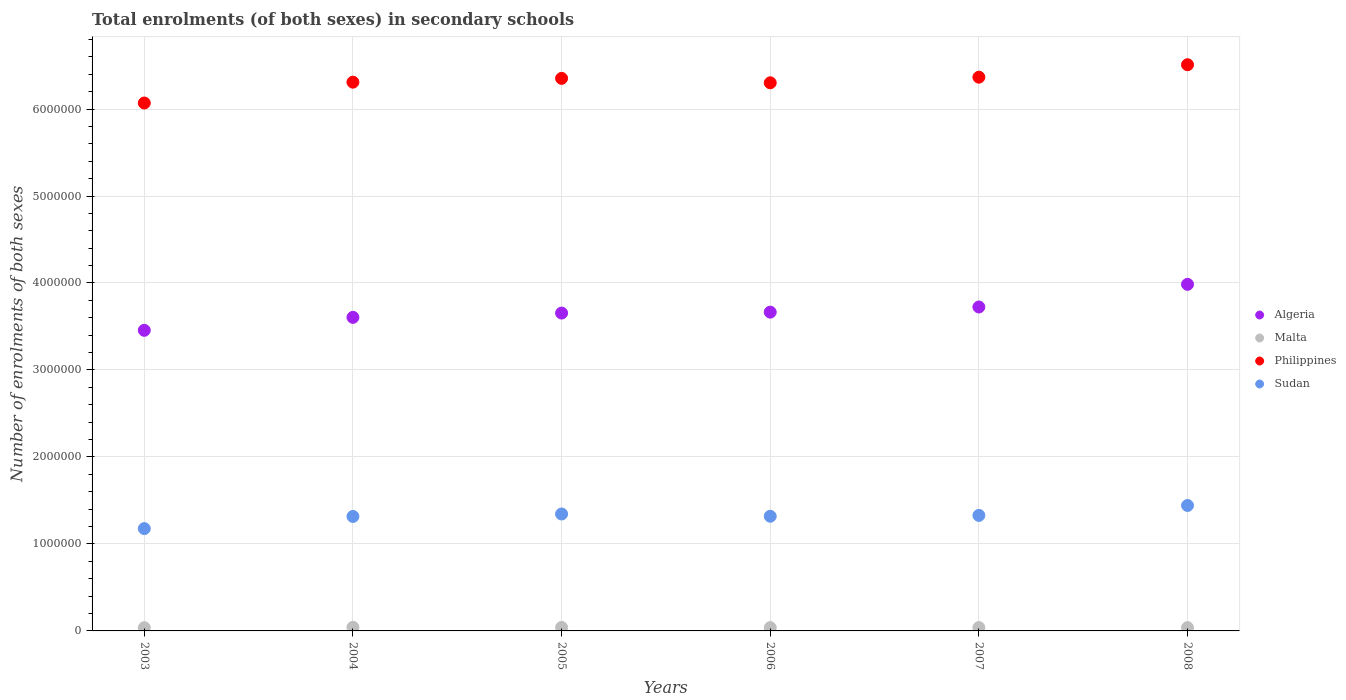What is the number of enrolments in secondary schools in Sudan in 2004?
Keep it short and to the point. 1.32e+06. Across all years, what is the maximum number of enrolments in secondary schools in Sudan?
Make the answer very short. 1.44e+06. Across all years, what is the minimum number of enrolments in secondary schools in Sudan?
Your response must be concise. 1.18e+06. In which year was the number of enrolments in secondary schools in Philippines maximum?
Offer a very short reply. 2008. In which year was the number of enrolments in secondary schools in Philippines minimum?
Keep it short and to the point. 2003. What is the total number of enrolments in secondary schools in Sudan in the graph?
Offer a very short reply. 7.92e+06. What is the difference between the number of enrolments in secondary schools in Philippines in 2007 and that in 2008?
Offer a terse response. -1.43e+05. What is the difference between the number of enrolments in secondary schools in Algeria in 2003 and the number of enrolments in secondary schools in Malta in 2008?
Keep it short and to the point. 3.42e+06. What is the average number of enrolments in secondary schools in Philippines per year?
Provide a short and direct response. 6.32e+06. In the year 2005, what is the difference between the number of enrolments in secondary schools in Sudan and number of enrolments in secondary schools in Philippines?
Make the answer very short. -5.01e+06. In how many years, is the number of enrolments in secondary schools in Algeria greater than 6600000?
Offer a terse response. 0. What is the ratio of the number of enrolments in secondary schools in Malta in 2004 to that in 2007?
Make the answer very short. 1.07. What is the difference between the highest and the second highest number of enrolments in secondary schools in Philippines?
Your answer should be compact. 1.43e+05. What is the difference between the highest and the lowest number of enrolments in secondary schools in Malta?
Provide a short and direct response. 4375. In how many years, is the number of enrolments in secondary schools in Philippines greater than the average number of enrolments in secondary schools in Philippines taken over all years?
Ensure brevity in your answer.  3. Is it the case that in every year, the sum of the number of enrolments in secondary schools in Sudan and number of enrolments in secondary schools in Malta  is greater than the number of enrolments in secondary schools in Algeria?
Your answer should be compact. No. Does the number of enrolments in secondary schools in Philippines monotonically increase over the years?
Your answer should be compact. No. Is the number of enrolments in secondary schools in Philippines strictly less than the number of enrolments in secondary schools in Malta over the years?
Your answer should be very brief. No. How many years are there in the graph?
Ensure brevity in your answer.  6. What is the difference between two consecutive major ticks on the Y-axis?
Provide a succinct answer. 1.00e+06. Does the graph contain grids?
Provide a short and direct response. Yes. What is the title of the graph?
Make the answer very short. Total enrolments (of both sexes) in secondary schools. What is the label or title of the X-axis?
Offer a terse response. Years. What is the label or title of the Y-axis?
Your response must be concise. Number of enrolments of both sexes. What is the Number of enrolments of both sexes in Algeria in 2003?
Make the answer very short. 3.46e+06. What is the Number of enrolments of both sexes in Malta in 2003?
Ensure brevity in your answer.  3.70e+04. What is the Number of enrolments of both sexes in Philippines in 2003?
Your answer should be very brief. 6.07e+06. What is the Number of enrolments of both sexes in Sudan in 2003?
Make the answer very short. 1.18e+06. What is the Number of enrolments of both sexes in Algeria in 2004?
Make the answer very short. 3.60e+06. What is the Number of enrolments of both sexes of Malta in 2004?
Your response must be concise. 4.14e+04. What is the Number of enrolments of both sexes in Philippines in 2004?
Make the answer very short. 6.31e+06. What is the Number of enrolments of both sexes of Sudan in 2004?
Ensure brevity in your answer.  1.32e+06. What is the Number of enrolments of both sexes of Algeria in 2005?
Your answer should be compact. 3.65e+06. What is the Number of enrolments of both sexes in Malta in 2005?
Your answer should be compact. 4.01e+04. What is the Number of enrolments of both sexes of Philippines in 2005?
Your answer should be compact. 6.35e+06. What is the Number of enrolments of both sexes of Sudan in 2005?
Offer a terse response. 1.34e+06. What is the Number of enrolments of both sexes in Algeria in 2006?
Your response must be concise. 3.66e+06. What is the Number of enrolments of both sexes of Malta in 2006?
Provide a succinct answer. 3.83e+04. What is the Number of enrolments of both sexes of Philippines in 2006?
Your answer should be very brief. 6.30e+06. What is the Number of enrolments of both sexes in Sudan in 2006?
Offer a very short reply. 1.32e+06. What is the Number of enrolments of both sexes in Algeria in 2007?
Provide a short and direct response. 3.72e+06. What is the Number of enrolments of both sexes of Malta in 2007?
Offer a very short reply. 3.85e+04. What is the Number of enrolments of both sexes in Philippines in 2007?
Your answer should be very brief. 6.37e+06. What is the Number of enrolments of both sexes of Sudan in 2007?
Your answer should be very brief. 1.33e+06. What is the Number of enrolments of both sexes in Algeria in 2008?
Make the answer very short. 3.98e+06. What is the Number of enrolments of both sexes of Malta in 2008?
Make the answer very short. 3.78e+04. What is the Number of enrolments of both sexes in Philippines in 2008?
Provide a succinct answer. 6.51e+06. What is the Number of enrolments of both sexes of Sudan in 2008?
Provide a short and direct response. 1.44e+06. Across all years, what is the maximum Number of enrolments of both sexes in Algeria?
Keep it short and to the point. 3.98e+06. Across all years, what is the maximum Number of enrolments of both sexes of Malta?
Offer a very short reply. 4.14e+04. Across all years, what is the maximum Number of enrolments of both sexes in Philippines?
Offer a terse response. 6.51e+06. Across all years, what is the maximum Number of enrolments of both sexes of Sudan?
Keep it short and to the point. 1.44e+06. Across all years, what is the minimum Number of enrolments of both sexes of Algeria?
Provide a short and direct response. 3.46e+06. Across all years, what is the minimum Number of enrolments of both sexes of Malta?
Your answer should be very brief. 3.70e+04. Across all years, what is the minimum Number of enrolments of both sexes in Philippines?
Your response must be concise. 6.07e+06. Across all years, what is the minimum Number of enrolments of both sexes in Sudan?
Your response must be concise. 1.18e+06. What is the total Number of enrolments of both sexes of Algeria in the graph?
Provide a short and direct response. 2.21e+07. What is the total Number of enrolments of both sexes of Malta in the graph?
Ensure brevity in your answer.  2.33e+05. What is the total Number of enrolments of both sexes in Philippines in the graph?
Ensure brevity in your answer.  3.79e+07. What is the total Number of enrolments of both sexes of Sudan in the graph?
Your answer should be very brief. 7.92e+06. What is the difference between the Number of enrolments of both sexes of Algeria in 2003 and that in 2004?
Ensure brevity in your answer.  -1.49e+05. What is the difference between the Number of enrolments of both sexes of Malta in 2003 and that in 2004?
Offer a terse response. -4375. What is the difference between the Number of enrolments of both sexes in Philippines in 2003 and that in 2004?
Your response must be concise. -2.40e+05. What is the difference between the Number of enrolments of both sexes in Sudan in 2003 and that in 2004?
Your answer should be very brief. -1.40e+05. What is the difference between the Number of enrolments of both sexes of Algeria in 2003 and that in 2005?
Offer a terse response. -1.98e+05. What is the difference between the Number of enrolments of both sexes in Malta in 2003 and that in 2005?
Your answer should be compact. -3151. What is the difference between the Number of enrolments of both sexes of Philippines in 2003 and that in 2005?
Offer a terse response. -2.83e+05. What is the difference between the Number of enrolments of both sexes of Sudan in 2003 and that in 2005?
Your answer should be compact. -1.68e+05. What is the difference between the Number of enrolments of both sexes of Algeria in 2003 and that in 2006?
Offer a terse response. -2.09e+05. What is the difference between the Number of enrolments of both sexes of Malta in 2003 and that in 2006?
Provide a succinct answer. -1357. What is the difference between the Number of enrolments of both sexes in Philippines in 2003 and that in 2006?
Make the answer very short. -2.33e+05. What is the difference between the Number of enrolments of both sexes of Sudan in 2003 and that in 2006?
Your response must be concise. -1.42e+05. What is the difference between the Number of enrolments of both sexes in Algeria in 2003 and that in 2007?
Offer a terse response. -2.68e+05. What is the difference between the Number of enrolments of both sexes of Malta in 2003 and that in 2007?
Keep it short and to the point. -1521. What is the difference between the Number of enrolments of both sexes of Philippines in 2003 and that in 2007?
Offer a terse response. -2.97e+05. What is the difference between the Number of enrolments of both sexes in Sudan in 2003 and that in 2007?
Offer a terse response. -1.52e+05. What is the difference between the Number of enrolments of both sexes of Algeria in 2003 and that in 2008?
Ensure brevity in your answer.  -5.29e+05. What is the difference between the Number of enrolments of both sexes of Malta in 2003 and that in 2008?
Your answer should be compact. -796. What is the difference between the Number of enrolments of both sexes in Philippines in 2003 and that in 2008?
Offer a terse response. -4.40e+05. What is the difference between the Number of enrolments of both sexes in Sudan in 2003 and that in 2008?
Your answer should be compact. -2.66e+05. What is the difference between the Number of enrolments of both sexes of Algeria in 2004 and that in 2005?
Your answer should be very brief. -4.94e+04. What is the difference between the Number of enrolments of both sexes in Malta in 2004 and that in 2005?
Offer a terse response. 1224. What is the difference between the Number of enrolments of both sexes of Philippines in 2004 and that in 2005?
Provide a succinct answer. -4.37e+04. What is the difference between the Number of enrolments of both sexes of Sudan in 2004 and that in 2005?
Provide a succinct answer. -2.83e+04. What is the difference between the Number of enrolments of both sexes of Algeria in 2004 and that in 2006?
Give a very brief answer. -6.01e+04. What is the difference between the Number of enrolments of both sexes in Malta in 2004 and that in 2006?
Provide a succinct answer. 3018. What is the difference between the Number of enrolments of both sexes of Philippines in 2004 and that in 2006?
Ensure brevity in your answer.  7210. What is the difference between the Number of enrolments of both sexes of Sudan in 2004 and that in 2006?
Your answer should be very brief. -2099. What is the difference between the Number of enrolments of both sexes of Algeria in 2004 and that in 2007?
Offer a very short reply. -1.19e+05. What is the difference between the Number of enrolments of both sexes of Malta in 2004 and that in 2007?
Provide a succinct answer. 2854. What is the difference between the Number of enrolments of both sexes of Philippines in 2004 and that in 2007?
Keep it short and to the point. -5.72e+04. What is the difference between the Number of enrolments of both sexes in Sudan in 2004 and that in 2007?
Provide a succinct answer. -1.19e+04. What is the difference between the Number of enrolments of both sexes of Algeria in 2004 and that in 2008?
Keep it short and to the point. -3.80e+05. What is the difference between the Number of enrolments of both sexes of Malta in 2004 and that in 2008?
Provide a short and direct response. 3579. What is the difference between the Number of enrolments of both sexes of Philippines in 2004 and that in 2008?
Offer a very short reply. -2.00e+05. What is the difference between the Number of enrolments of both sexes in Sudan in 2004 and that in 2008?
Provide a succinct answer. -1.26e+05. What is the difference between the Number of enrolments of both sexes in Algeria in 2005 and that in 2006?
Keep it short and to the point. -1.06e+04. What is the difference between the Number of enrolments of both sexes of Malta in 2005 and that in 2006?
Give a very brief answer. 1794. What is the difference between the Number of enrolments of both sexes in Philippines in 2005 and that in 2006?
Provide a succinct answer. 5.09e+04. What is the difference between the Number of enrolments of both sexes in Sudan in 2005 and that in 2006?
Your response must be concise. 2.62e+04. What is the difference between the Number of enrolments of both sexes of Algeria in 2005 and that in 2007?
Make the answer very short. -6.99e+04. What is the difference between the Number of enrolments of both sexes in Malta in 2005 and that in 2007?
Your answer should be compact. 1630. What is the difference between the Number of enrolments of both sexes of Philippines in 2005 and that in 2007?
Your response must be concise. -1.35e+04. What is the difference between the Number of enrolments of both sexes of Sudan in 2005 and that in 2007?
Your answer should be compact. 1.64e+04. What is the difference between the Number of enrolments of both sexes in Algeria in 2005 and that in 2008?
Offer a very short reply. -3.30e+05. What is the difference between the Number of enrolments of both sexes of Malta in 2005 and that in 2008?
Ensure brevity in your answer.  2355. What is the difference between the Number of enrolments of both sexes of Philippines in 2005 and that in 2008?
Make the answer very short. -1.57e+05. What is the difference between the Number of enrolments of both sexes in Sudan in 2005 and that in 2008?
Your answer should be very brief. -9.78e+04. What is the difference between the Number of enrolments of both sexes of Algeria in 2006 and that in 2007?
Keep it short and to the point. -5.92e+04. What is the difference between the Number of enrolments of both sexes of Malta in 2006 and that in 2007?
Your answer should be very brief. -164. What is the difference between the Number of enrolments of both sexes in Philippines in 2006 and that in 2007?
Provide a short and direct response. -6.44e+04. What is the difference between the Number of enrolments of both sexes in Sudan in 2006 and that in 2007?
Your answer should be very brief. -9811. What is the difference between the Number of enrolments of both sexes in Algeria in 2006 and that in 2008?
Your answer should be compact. -3.20e+05. What is the difference between the Number of enrolments of both sexes of Malta in 2006 and that in 2008?
Make the answer very short. 561. What is the difference between the Number of enrolments of both sexes in Philippines in 2006 and that in 2008?
Make the answer very short. -2.08e+05. What is the difference between the Number of enrolments of both sexes in Sudan in 2006 and that in 2008?
Make the answer very short. -1.24e+05. What is the difference between the Number of enrolments of both sexes of Algeria in 2007 and that in 2008?
Provide a succinct answer. -2.60e+05. What is the difference between the Number of enrolments of both sexes in Malta in 2007 and that in 2008?
Provide a short and direct response. 725. What is the difference between the Number of enrolments of both sexes of Philippines in 2007 and that in 2008?
Ensure brevity in your answer.  -1.43e+05. What is the difference between the Number of enrolments of both sexes in Sudan in 2007 and that in 2008?
Make the answer very short. -1.14e+05. What is the difference between the Number of enrolments of both sexes of Algeria in 2003 and the Number of enrolments of both sexes of Malta in 2004?
Keep it short and to the point. 3.41e+06. What is the difference between the Number of enrolments of both sexes of Algeria in 2003 and the Number of enrolments of both sexes of Philippines in 2004?
Provide a succinct answer. -2.85e+06. What is the difference between the Number of enrolments of both sexes of Algeria in 2003 and the Number of enrolments of both sexes of Sudan in 2004?
Keep it short and to the point. 2.14e+06. What is the difference between the Number of enrolments of both sexes of Malta in 2003 and the Number of enrolments of both sexes of Philippines in 2004?
Your answer should be compact. -6.27e+06. What is the difference between the Number of enrolments of both sexes in Malta in 2003 and the Number of enrolments of both sexes in Sudan in 2004?
Your answer should be compact. -1.28e+06. What is the difference between the Number of enrolments of both sexes in Philippines in 2003 and the Number of enrolments of both sexes in Sudan in 2004?
Provide a succinct answer. 4.75e+06. What is the difference between the Number of enrolments of both sexes in Algeria in 2003 and the Number of enrolments of both sexes in Malta in 2005?
Keep it short and to the point. 3.42e+06. What is the difference between the Number of enrolments of both sexes of Algeria in 2003 and the Number of enrolments of both sexes of Philippines in 2005?
Keep it short and to the point. -2.90e+06. What is the difference between the Number of enrolments of both sexes in Algeria in 2003 and the Number of enrolments of both sexes in Sudan in 2005?
Give a very brief answer. 2.11e+06. What is the difference between the Number of enrolments of both sexes in Malta in 2003 and the Number of enrolments of both sexes in Philippines in 2005?
Make the answer very short. -6.32e+06. What is the difference between the Number of enrolments of both sexes of Malta in 2003 and the Number of enrolments of both sexes of Sudan in 2005?
Give a very brief answer. -1.31e+06. What is the difference between the Number of enrolments of both sexes of Philippines in 2003 and the Number of enrolments of both sexes of Sudan in 2005?
Provide a succinct answer. 4.72e+06. What is the difference between the Number of enrolments of both sexes of Algeria in 2003 and the Number of enrolments of both sexes of Malta in 2006?
Ensure brevity in your answer.  3.42e+06. What is the difference between the Number of enrolments of both sexes of Algeria in 2003 and the Number of enrolments of both sexes of Philippines in 2006?
Give a very brief answer. -2.85e+06. What is the difference between the Number of enrolments of both sexes of Algeria in 2003 and the Number of enrolments of both sexes of Sudan in 2006?
Offer a very short reply. 2.14e+06. What is the difference between the Number of enrolments of both sexes in Malta in 2003 and the Number of enrolments of both sexes in Philippines in 2006?
Provide a succinct answer. -6.26e+06. What is the difference between the Number of enrolments of both sexes of Malta in 2003 and the Number of enrolments of both sexes of Sudan in 2006?
Your answer should be compact. -1.28e+06. What is the difference between the Number of enrolments of both sexes in Philippines in 2003 and the Number of enrolments of both sexes in Sudan in 2006?
Your answer should be very brief. 4.75e+06. What is the difference between the Number of enrolments of both sexes of Algeria in 2003 and the Number of enrolments of both sexes of Malta in 2007?
Offer a very short reply. 3.42e+06. What is the difference between the Number of enrolments of both sexes of Algeria in 2003 and the Number of enrolments of both sexes of Philippines in 2007?
Provide a short and direct response. -2.91e+06. What is the difference between the Number of enrolments of both sexes of Algeria in 2003 and the Number of enrolments of both sexes of Sudan in 2007?
Provide a succinct answer. 2.13e+06. What is the difference between the Number of enrolments of both sexes in Malta in 2003 and the Number of enrolments of both sexes in Philippines in 2007?
Provide a succinct answer. -6.33e+06. What is the difference between the Number of enrolments of both sexes in Malta in 2003 and the Number of enrolments of both sexes in Sudan in 2007?
Offer a terse response. -1.29e+06. What is the difference between the Number of enrolments of both sexes in Philippines in 2003 and the Number of enrolments of both sexes in Sudan in 2007?
Provide a short and direct response. 4.74e+06. What is the difference between the Number of enrolments of both sexes of Algeria in 2003 and the Number of enrolments of both sexes of Malta in 2008?
Keep it short and to the point. 3.42e+06. What is the difference between the Number of enrolments of both sexes of Algeria in 2003 and the Number of enrolments of both sexes of Philippines in 2008?
Provide a short and direct response. -3.05e+06. What is the difference between the Number of enrolments of both sexes of Algeria in 2003 and the Number of enrolments of both sexes of Sudan in 2008?
Keep it short and to the point. 2.01e+06. What is the difference between the Number of enrolments of both sexes of Malta in 2003 and the Number of enrolments of both sexes of Philippines in 2008?
Make the answer very short. -6.47e+06. What is the difference between the Number of enrolments of both sexes of Malta in 2003 and the Number of enrolments of both sexes of Sudan in 2008?
Give a very brief answer. -1.41e+06. What is the difference between the Number of enrolments of both sexes of Philippines in 2003 and the Number of enrolments of both sexes of Sudan in 2008?
Provide a succinct answer. 4.63e+06. What is the difference between the Number of enrolments of both sexes of Algeria in 2004 and the Number of enrolments of both sexes of Malta in 2005?
Provide a succinct answer. 3.56e+06. What is the difference between the Number of enrolments of both sexes in Algeria in 2004 and the Number of enrolments of both sexes in Philippines in 2005?
Give a very brief answer. -2.75e+06. What is the difference between the Number of enrolments of both sexes of Algeria in 2004 and the Number of enrolments of both sexes of Sudan in 2005?
Keep it short and to the point. 2.26e+06. What is the difference between the Number of enrolments of both sexes of Malta in 2004 and the Number of enrolments of both sexes of Philippines in 2005?
Provide a succinct answer. -6.31e+06. What is the difference between the Number of enrolments of both sexes in Malta in 2004 and the Number of enrolments of both sexes in Sudan in 2005?
Offer a very short reply. -1.30e+06. What is the difference between the Number of enrolments of both sexes in Philippines in 2004 and the Number of enrolments of both sexes in Sudan in 2005?
Make the answer very short. 4.96e+06. What is the difference between the Number of enrolments of both sexes of Algeria in 2004 and the Number of enrolments of both sexes of Malta in 2006?
Your response must be concise. 3.57e+06. What is the difference between the Number of enrolments of both sexes of Algeria in 2004 and the Number of enrolments of both sexes of Philippines in 2006?
Offer a very short reply. -2.70e+06. What is the difference between the Number of enrolments of both sexes in Algeria in 2004 and the Number of enrolments of both sexes in Sudan in 2006?
Provide a succinct answer. 2.29e+06. What is the difference between the Number of enrolments of both sexes of Malta in 2004 and the Number of enrolments of both sexes of Philippines in 2006?
Your answer should be very brief. -6.26e+06. What is the difference between the Number of enrolments of both sexes of Malta in 2004 and the Number of enrolments of both sexes of Sudan in 2006?
Your answer should be very brief. -1.28e+06. What is the difference between the Number of enrolments of both sexes in Philippines in 2004 and the Number of enrolments of both sexes in Sudan in 2006?
Keep it short and to the point. 4.99e+06. What is the difference between the Number of enrolments of both sexes in Algeria in 2004 and the Number of enrolments of both sexes in Malta in 2007?
Provide a succinct answer. 3.57e+06. What is the difference between the Number of enrolments of both sexes in Algeria in 2004 and the Number of enrolments of both sexes in Philippines in 2007?
Offer a very short reply. -2.76e+06. What is the difference between the Number of enrolments of both sexes in Algeria in 2004 and the Number of enrolments of both sexes in Sudan in 2007?
Make the answer very short. 2.28e+06. What is the difference between the Number of enrolments of both sexes of Malta in 2004 and the Number of enrolments of both sexes of Philippines in 2007?
Your answer should be very brief. -6.32e+06. What is the difference between the Number of enrolments of both sexes in Malta in 2004 and the Number of enrolments of both sexes in Sudan in 2007?
Provide a succinct answer. -1.29e+06. What is the difference between the Number of enrolments of both sexes of Philippines in 2004 and the Number of enrolments of both sexes of Sudan in 2007?
Offer a very short reply. 4.98e+06. What is the difference between the Number of enrolments of both sexes of Algeria in 2004 and the Number of enrolments of both sexes of Malta in 2008?
Your answer should be very brief. 3.57e+06. What is the difference between the Number of enrolments of both sexes of Algeria in 2004 and the Number of enrolments of both sexes of Philippines in 2008?
Your response must be concise. -2.90e+06. What is the difference between the Number of enrolments of both sexes of Algeria in 2004 and the Number of enrolments of both sexes of Sudan in 2008?
Provide a short and direct response. 2.16e+06. What is the difference between the Number of enrolments of both sexes of Malta in 2004 and the Number of enrolments of both sexes of Philippines in 2008?
Offer a terse response. -6.47e+06. What is the difference between the Number of enrolments of both sexes of Malta in 2004 and the Number of enrolments of both sexes of Sudan in 2008?
Provide a short and direct response. -1.40e+06. What is the difference between the Number of enrolments of both sexes in Philippines in 2004 and the Number of enrolments of both sexes in Sudan in 2008?
Provide a short and direct response. 4.87e+06. What is the difference between the Number of enrolments of both sexes in Algeria in 2005 and the Number of enrolments of both sexes in Malta in 2006?
Your response must be concise. 3.62e+06. What is the difference between the Number of enrolments of both sexes in Algeria in 2005 and the Number of enrolments of both sexes in Philippines in 2006?
Ensure brevity in your answer.  -2.65e+06. What is the difference between the Number of enrolments of both sexes of Algeria in 2005 and the Number of enrolments of both sexes of Sudan in 2006?
Your response must be concise. 2.34e+06. What is the difference between the Number of enrolments of both sexes in Malta in 2005 and the Number of enrolments of both sexes in Philippines in 2006?
Provide a short and direct response. -6.26e+06. What is the difference between the Number of enrolments of both sexes in Malta in 2005 and the Number of enrolments of both sexes in Sudan in 2006?
Make the answer very short. -1.28e+06. What is the difference between the Number of enrolments of both sexes of Philippines in 2005 and the Number of enrolments of both sexes of Sudan in 2006?
Give a very brief answer. 5.03e+06. What is the difference between the Number of enrolments of both sexes in Algeria in 2005 and the Number of enrolments of both sexes in Malta in 2007?
Offer a terse response. 3.62e+06. What is the difference between the Number of enrolments of both sexes of Algeria in 2005 and the Number of enrolments of both sexes of Philippines in 2007?
Your answer should be very brief. -2.71e+06. What is the difference between the Number of enrolments of both sexes in Algeria in 2005 and the Number of enrolments of both sexes in Sudan in 2007?
Provide a short and direct response. 2.33e+06. What is the difference between the Number of enrolments of both sexes in Malta in 2005 and the Number of enrolments of both sexes in Philippines in 2007?
Your answer should be compact. -6.33e+06. What is the difference between the Number of enrolments of both sexes of Malta in 2005 and the Number of enrolments of both sexes of Sudan in 2007?
Keep it short and to the point. -1.29e+06. What is the difference between the Number of enrolments of both sexes of Philippines in 2005 and the Number of enrolments of both sexes of Sudan in 2007?
Ensure brevity in your answer.  5.02e+06. What is the difference between the Number of enrolments of both sexes in Algeria in 2005 and the Number of enrolments of both sexes in Malta in 2008?
Your answer should be compact. 3.62e+06. What is the difference between the Number of enrolments of both sexes of Algeria in 2005 and the Number of enrolments of both sexes of Philippines in 2008?
Provide a short and direct response. -2.86e+06. What is the difference between the Number of enrolments of both sexes of Algeria in 2005 and the Number of enrolments of both sexes of Sudan in 2008?
Offer a very short reply. 2.21e+06. What is the difference between the Number of enrolments of both sexes of Malta in 2005 and the Number of enrolments of both sexes of Philippines in 2008?
Offer a very short reply. -6.47e+06. What is the difference between the Number of enrolments of both sexes in Malta in 2005 and the Number of enrolments of both sexes in Sudan in 2008?
Provide a short and direct response. -1.40e+06. What is the difference between the Number of enrolments of both sexes of Philippines in 2005 and the Number of enrolments of both sexes of Sudan in 2008?
Offer a very short reply. 4.91e+06. What is the difference between the Number of enrolments of both sexes of Algeria in 2006 and the Number of enrolments of both sexes of Malta in 2007?
Offer a very short reply. 3.63e+06. What is the difference between the Number of enrolments of both sexes in Algeria in 2006 and the Number of enrolments of both sexes in Philippines in 2007?
Ensure brevity in your answer.  -2.70e+06. What is the difference between the Number of enrolments of both sexes of Algeria in 2006 and the Number of enrolments of both sexes of Sudan in 2007?
Offer a very short reply. 2.34e+06. What is the difference between the Number of enrolments of both sexes in Malta in 2006 and the Number of enrolments of both sexes in Philippines in 2007?
Offer a very short reply. -6.33e+06. What is the difference between the Number of enrolments of both sexes of Malta in 2006 and the Number of enrolments of both sexes of Sudan in 2007?
Offer a very short reply. -1.29e+06. What is the difference between the Number of enrolments of both sexes of Philippines in 2006 and the Number of enrolments of both sexes of Sudan in 2007?
Offer a very short reply. 4.97e+06. What is the difference between the Number of enrolments of both sexes in Algeria in 2006 and the Number of enrolments of both sexes in Malta in 2008?
Your response must be concise. 3.63e+06. What is the difference between the Number of enrolments of both sexes of Algeria in 2006 and the Number of enrolments of both sexes of Philippines in 2008?
Your answer should be very brief. -2.84e+06. What is the difference between the Number of enrolments of both sexes in Algeria in 2006 and the Number of enrolments of both sexes in Sudan in 2008?
Provide a short and direct response. 2.22e+06. What is the difference between the Number of enrolments of both sexes of Malta in 2006 and the Number of enrolments of both sexes of Philippines in 2008?
Make the answer very short. -6.47e+06. What is the difference between the Number of enrolments of both sexes in Malta in 2006 and the Number of enrolments of both sexes in Sudan in 2008?
Your response must be concise. -1.40e+06. What is the difference between the Number of enrolments of both sexes of Philippines in 2006 and the Number of enrolments of both sexes of Sudan in 2008?
Provide a short and direct response. 4.86e+06. What is the difference between the Number of enrolments of both sexes of Algeria in 2007 and the Number of enrolments of both sexes of Malta in 2008?
Your response must be concise. 3.69e+06. What is the difference between the Number of enrolments of both sexes in Algeria in 2007 and the Number of enrolments of both sexes in Philippines in 2008?
Offer a terse response. -2.79e+06. What is the difference between the Number of enrolments of both sexes in Algeria in 2007 and the Number of enrolments of both sexes in Sudan in 2008?
Your response must be concise. 2.28e+06. What is the difference between the Number of enrolments of both sexes of Malta in 2007 and the Number of enrolments of both sexes of Philippines in 2008?
Your answer should be very brief. -6.47e+06. What is the difference between the Number of enrolments of both sexes of Malta in 2007 and the Number of enrolments of both sexes of Sudan in 2008?
Your answer should be very brief. -1.40e+06. What is the difference between the Number of enrolments of both sexes in Philippines in 2007 and the Number of enrolments of both sexes in Sudan in 2008?
Your answer should be very brief. 4.92e+06. What is the average Number of enrolments of both sexes of Algeria per year?
Ensure brevity in your answer.  3.68e+06. What is the average Number of enrolments of both sexes of Malta per year?
Provide a succinct answer. 3.88e+04. What is the average Number of enrolments of both sexes in Philippines per year?
Make the answer very short. 6.32e+06. What is the average Number of enrolments of both sexes in Sudan per year?
Offer a terse response. 1.32e+06. In the year 2003, what is the difference between the Number of enrolments of both sexes of Algeria and Number of enrolments of both sexes of Malta?
Offer a terse response. 3.42e+06. In the year 2003, what is the difference between the Number of enrolments of both sexes of Algeria and Number of enrolments of both sexes of Philippines?
Offer a terse response. -2.61e+06. In the year 2003, what is the difference between the Number of enrolments of both sexes of Algeria and Number of enrolments of both sexes of Sudan?
Offer a terse response. 2.28e+06. In the year 2003, what is the difference between the Number of enrolments of both sexes of Malta and Number of enrolments of both sexes of Philippines?
Offer a terse response. -6.03e+06. In the year 2003, what is the difference between the Number of enrolments of both sexes of Malta and Number of enrolments of both sexes of Sudan?
Ensure brevity in your answer.  -1.14e+06. In the year 2003, what is the difference between the Number of enrolments of both sexes in Philippines and Number of enrolments of both sexes in Sudan?
Your answer should be very brief. 4.89e+06. In the year 2004, what is the difference between the Number of enrolments of both sexes in Algeria and Number of enrolments of both sexes in Malta?
Give a very brief answer. 3.56e+06. In the year 2004, what is the difference between the Number of enrolments of both sexes of Algeria and Number of enrolments of both sexes of Philippines?
Your response must be concise. -2.70e+06. In the year 2004, what is the difference between the Number of enrolments of both sexes in Algeria and Number of enrolments of both sexes in Sudan?
Provide a succinct answer. 2.29e+06. In the year 2004, what is the difference between the Number of enrolments of both sexes in Malta and Number of enrolments of both sexes in Philippines?
Make the answer very short. -6.27e+06. In the year 2004, what is the difference between the Number of enrolments of both sexes of Malta and Number of enrolments of both sexes of Sudan?
Your response must be concise. -1.27e+06. In the year 2004, what is the difference between the Number of enrolments of both sexes in Philippines and Number of enrolments of both sexes in Sudan?
Your answer should be compact. 4.99e+06. In the year 2005, what is the difference between the Number of enrolments of both sexes in Algeria and Number of enrolments of both sexes in Malta?
Offer a very short reply. 3.61e+06. In the year 2005, what is the difference between the Number of enrolments of both sexes in Algeria and Number of enrolments of both sexes in Philippines?
Ensure brevity in your answer.  -2.70e+06. In the year 2005, what is the difference between the Number of enrolments of both sexes in Algeria and Number of enrolments of both sexes in Sudan?
Make the answer very short. 2.31e+06. In the year 2005, what is the difference between the Number of enrolments of both sexes of Malta and Number of enrolments of both sexes of Philippines?
Give a very brief answer. -6.31e+06. In the year 2005, what is the difference between the Number of enrolments of both sexes of Malta and Number of enrolments of both sexes of Sudan?
Offer a very short reply. -1.30e+06. In the year 2005, what is the difference between the Number of enrolments of both sexes of Philippines and Number of enrolments of both sexes of Sudan?
Ensure brevity in your answer.  5.01e+06. In the year 2006, what is the difference between the Number of enrolments of both sexes of Algeria and Number of enrolments of both sexes of Malta?
Make the answer very short. 3.63e+06. In the year 2006, what is the difference between the Number of enrolments of both sexes of Algeria and Number of enrolments of both sexes of Philippines?
Give a very brief answer. -2.64e+06. In the year 2006, what is the difference between the Number of enrolments of both sexes in Algeria and Number of enrolments of both sexes in Sudan?
Offer a terse response. 2.35e+06. In the year 2006, what is the difference between the Number of enrolments of both sexes in Malta and Number of enrolments of both sexes in Philippines?
Make the answer very short. -6.26e+06. In the year 2006, what is the difference between the Number of enrolments of both sexes of Malta and Number of enrolments of both sexes of Sudan?
Offer a terse response. -1.28e+06. In the year 2006, what is the difference between the Number of enrolments of both sexes in Philippines and Number of enrolments of both sexes in Sudan?
Offer a very short reply. 4.98e+06. In the year 2007, what is the difference between the Number of enrolments of both sexes of Algeria and Number of enrolments of both sexes of Malta?
Keep it short and to the point. 3.69e+06. In the year 2007, what is the difference between the Number of enrolments of both sexes of Algeria and Number of enrolments of both sexes of Philippines?
Offer a very short reply. -2.64e+06. In the year 2007, what is the difference between the Number of enrolments of both sexes of Algeria and Number of enrolments of both sexes of Sudan?
Ensure brevity in your answer.  2.40e+06. In the year 2007, what is the difference between the Number of enrolments of both sexes of Malta and Number of enrolments of both sexes of Philippines?
Provide a succinct answer. -6.33e+06. In the year 2007, what is the difference between the Number of enrolments of both sexes of Malta and Number of enrolments of both sexes of Sudan?
Ensure brevity in your answer.  -1.29e+06. In the year 2007, what is the difference between the Number of enrolments of both sexes in Philippines and Number of enrolments of both sexes in Sudan?
Ensure brevity in your answer.  5.04e+06. In the year 2008, what is the difference between the Number of enrolments of both sexes of Algeria and Number of enrolments of both sexes of Malta?
Provide a short and direct response. 3.95e+06. In the year 2008, what is the difference between the Number of enrolments of both sexes in Algeria and Number of enrolments of both sexes in Philippines?
Provide a succinct answer. -2.52e+06. In the year 2008, what is the difference between the Number of enrolments of both sexes in Algeria and Number of enrolments of both sexes in Sudan?
Offer a very short reply. 2.54e+06. In the year 2008, what is the difference between the Number of enrolments of both sexes of Malta and Number of enrolments of both sexes of Philippines?
Your response must be concise. -6.47e+06. In the year 2008, what is the difference between the Number of enrolments of both sexes in Malta and Number of enrolments of both sexes in Sudan?
Your answer should be compact. -1.40e+06. In the year 2008, what is the difference between the Number of enrolments of both sexes in Philippines and Number of enrolments of both sexes in Sudan?
Your response must be concise. 5.07e+06. What is the ratio of the Number of enrolments of both sexes in Algeria in 2003 to that in 2004?
Offer a terse response. 0.96. What is the ratio of the Number of enrolments of both sexes of Malta in 2003 to that in 2004?
Keep it short and to the point. 0.89. What is the ratio of the Number of enrolments of both sexes of Philippines in 2003 to that in 2004?
Offer a terse response. 0.96. What is the ratio of the Number of enrolments of both sexes of Sudan in 2003 to that in 2004?
Your response must be concise. 0.89. What is the ratio of the Number of enrolments of both sexes of Algeria in 2003 to that in 2005?
Your answer should be compact. 0.95. What is the ratio of the Number of enrolments of both sexes in Malta in 2003 to that in 2005?
Your answer should be compact. 0.92. What is the ratio of the Number of enrolments of both sexes in Philippines in 2003 to that in 2005?
Make the answer very short. 0.96. What is the ratio of the Number of enrolments of both sexes in Sudan in 2003 to that in 2005?
Keep it short and to the point. 0.88. What is the ratio of the Number of enrolments of both sexes in Algeria in 2003 to that in 2006?
Your answer should be very brief. 0.94. What is the ratio of the Number of enrolments of both sexes in Malta in 2003 to that in 2006?
Ensure brevity in your answer.  0.96. What is the ratio of the Number of enrolments of both sexes in Philippines in 2003 to that in 2006?
Your answer should be compact. 0.96. What is the ratio of the Number of enrolments of both sexes in Sudan in 2003 to that in 2006?
Your response must be concise. 0.89. What is the ratio of the Number of enrolments of both sexes of Algeria in 2003 to that in 2007?
Your response must be concise. 0.93. What is the ratio of the Number of enrolments of both sexes in Malta in 2003 to that in 2007?
Your answer should be compact. 0.96. What is the ratio of the Number of enrolments of both sexes of Philippines in 2003 to that in 2007?
Your response must be concise. 0.95. What is the ratio of the Number of enrolments of both sexes of Sudan in 2003 to that in 2007?
Offer a very short reply. 0.89. What is the ratio of the Number of enrolments of both sexes of Algeria in 2003 to that in 2008?
Your answer should be compact. 0.87. What is the ratio of the Number of enrolments of both sexes in Malta in 2003 to that in 2008?
Keep it short and to the point. 0.98. What is the ratio of the Number of enrolments of both sexes of Philippines in 2003 to that in 2008?
Offer a very short reply. 0.93. What is the ratio of the Number of enrolments of both sexes of Sudan in 2003 to that in 2008?
Give a very brief answer. 0.82. What is the ratio of the Number of enrolments of both sexes of Algeria in 2004 to that in 2005?
Give a very brief answer. 0.99. What is the ratio of the Number of enrolments of both sexes of Malta in 2004 to that in 2005?
Your answer should be very brief. 1.03. What is the ratio of the Number of enrolments of both sexes in Sudan in 2004 to that in 2005?
Make the answer very short. 0.98. What is the ratio of the Number of enrolments of both sexes of Algeria in 2004 to that in 2006?
Provide a succinct answer. 0.98. What is the ratio of the Number of enrolments of both sexes of Malta in 2004 to that in 2006?
Provide a short and direct response. 1.08. What is the ratio of the Number of enrolments of both sexes in Philippines in 2004 to that in 2006?
Provide a succinct answer. 1. What is the ratio of the Number of enrolments of both sexes in Malta in 2004 to that in 2007?
Offer a very short reply. 1.07. What is the ratio of the Number of enrolments of both sexes of Philippines in 2004 to that in 2007?
Give a very brief answer. 0.99. What is the ratio of the Number of enrolments of both sexes in Sudan in 2004 to that in 2007?
Keep it short and to the point. 0.99. What is the ratio of the Number of enrolments of both sexes in Algeria in 2004 to that in 2008?
Make the answer very short. 0.9. What is the ratio of the Number of enrolments of both sexes of Malta in 2004 to that in 2008?
Your answer should be compact. 1.09. What is the ratio of the Number of enrolments of both sexes in Philippines in 2004 to that in 2008?
Provide a succinct answer. 0.97. What is the ratio of the Number of enrolments of both sexes of Sudan in 2004 to that in 2008?
Your response must be concise. 0.91. What is the ratio of the Number of enrolments of both sexes of Malta in 2005 to that in 2006?
Offer a very short reply. 1.05. What is the ratio of the Number of enrolments of both sexes of Sudan in 2005 to that in 2006?
Provide a short and direct response. 1.02. What is the ratio of the Number of enrolments of both sexes in Algeria in 2005 to that in 2007?
Offer a very short reply. 0.98. What is the ratio of the Number of enrolments of both sexes of Malta in 2005 to that in 2007?
Your answer should be very brief. 1.04. What is the ratio of the Number of enrolments of both sexes of Sudan in 2005 to that in 2007?
Your answer should be very brief. 1.01. What is the ratio of the Number of enrolments of both sexes in Algeria in 2005 to that in 2008?
Ensure brevity in your answer.  0.92. What is the ratio of the Number of enrolments of both sexes of Malta in 2005 to that in 2008?
Your response must be concise. 1.06. What is the ratio of the Number of enrolments of both sexes of Philippines in 2005 to that in 2008?
Provide a succinct answer. 0.98. What is the ratio of the Number of enrolments of both sexes in Sudan in 2005 to that in 2008?
Ensure brevity in your answer.  0.93. What is the ratio of the Number of enrolments of both sexes in Algeria in 2006 to that in 2007?
Offer a very short reply. 0.98. What is the ratio of the Number of enrolments of both sexes in Malta in 2006 to that in 2007?
Your response must be concise. 1. What is the ratio of the Number of enrolments of both sexes of Philippines in 2006 to that in 2007?
Provide a short and direct response. 0.99. What is the ratio of the Number of enrolments of both sexes in Sudan in 2006 to that in 2007?
Give a very brief answer. 0.99. What is the ratio of the Number of enrolments of both sexes of Algeria in 2006 to that in 2008?
Offer a terse response. 0.92. What is the ratio of the Number of enrolments of both sexes in Malta in 2006 to that in 2008?
Provide a short and direct response. 1.01. What is the ratio of the Number of enrolments of both sexes of Philippines in 2006 to that in 2008?
Provide a succinct answer. 0.97. What is the ratio of the Number of enrolments of both sexes in Sudan in 2006 to that in 2008?
Give a very brief answer. 0.91. What is the ratio of the Number of enrolments of both sexes of Algeria in 2007 to that in 2008?
Keep it short and to the point. 0.93. What is the ratio of the Number of enrolments of both sexes in Malta in 2007 to that in 2008?
Your response must be concise. 1.02. What is the ratio of the Number of enrolments of both sexes of Sudan in 2007 to that in 2008?
Offer a terse response. 0.92. What is the difference between the highest and the second highest Number of enrolments of both sexes of Algeria?
Offer a terse response. 2.60e+05. What is the difference between the highest and the second highest Number of enrolments of both sexes in Malta?
Your answer should be compact. 1224. What is the difference between the highest and the second highest Number of enrolments of both sexes of Philippines?
Give a very brief answer. 1.43e+05. What is the difference between the highest and the second highest Number of enrolments of both sexes in Sudan?
Provide a short and direct response. 9.78e+04. What is the difference between the highest and the lowest Number of enrolments of both sexes of Algeria?
Offer a very short reply. 5.29e+05. What is the difference between the highest and the lowest Number of enrolments of both sexes of Malta?
Offer a terse response. 4375. What is the difference between the highest and the lowest Number of enrolments of both sexes in Philippines?
Your answer should be compact. 4.40e+05. What is the difference between the highest and the lowest Number of enrolments of both sexes in Sudan?
Your answer should be compact. 2.66e+05. 